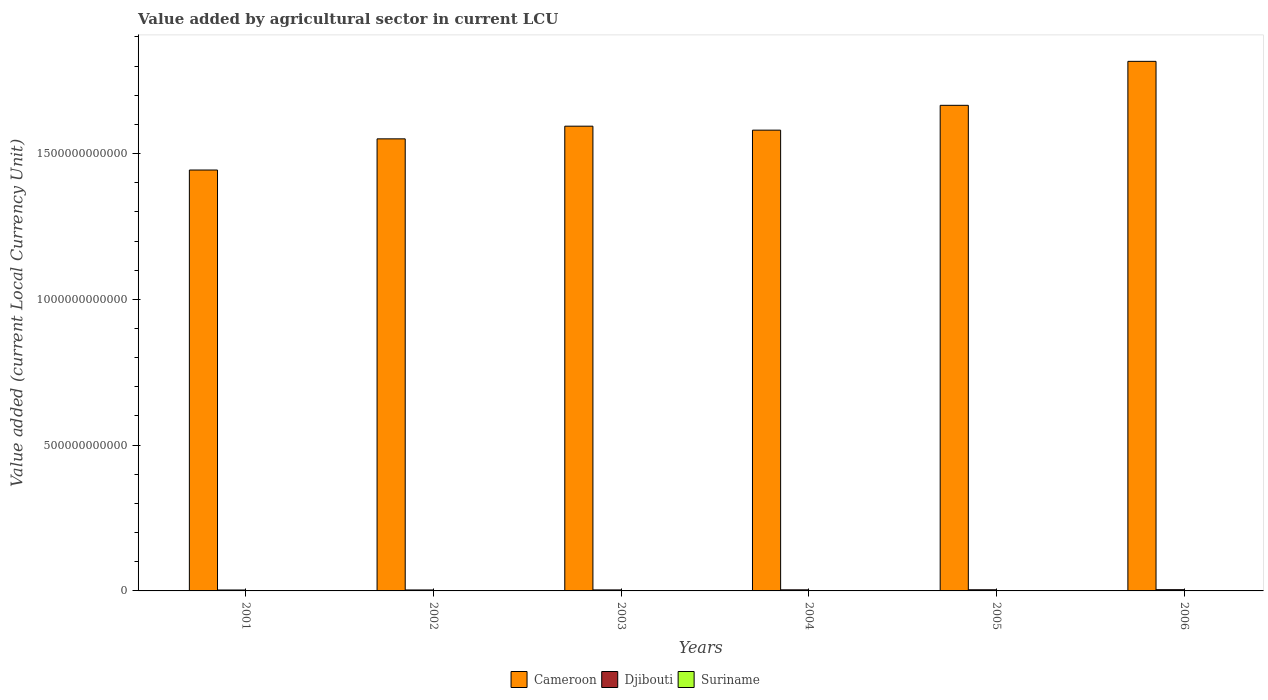Are the number of bars per tick equal to the number of legend labels?
Offer a terse response. Yes. How many bars are there on the 1st tick from the right?
Keep it short and to the point. 3. What is the label of the 4th group of bars from the left?
Your response must be concise. 2004. In how many cases, is the number of bars for a given year not equal to the number of legend labels?
Give a very brief answer. 0. What is the value added by agricultural sector in Djibouti in 2001?
Offer a very short reply. 3.18e+09. Across all years, what is the maximum value added by agricultural sector in Cameroon?
Your answer should be compact. 1.82e+12. Across all years, what is the minimum value added by agricultural sector in Suriname?
Your answer should be compact. 1.65e+08. What is the total value added by agricultural sector in Suriname in the graph?
Keep it short and to the point. 1.75e+09. What is the difference between the value added by agricultural sector in Suriname in 2005 and that in 2006?
Offer a very short reply. -4.93e+08. What is the difference between the value added by agricultural sector in Suriname in 2003 and the value added by agricultural sector in Djibouti in 2004?
Make the answer very short. -3.51e+09. What is the average value added by agricultural sector in Cameroon per year?
Offer a terse response. 1.61e+12. In the year 2006, what is the difference between the value added by agricultural sector in Cameroon and value added by agricultural sector in Suriname?
Provide a succinct answer. 1.82e+12. What is the ratio of the value added by agricultural sector in Djibouti in 2002 to that in 2004?
Provide a short and direct response. 0.88. Is the value added by agricultural sector in Suriname in 2002 less than that in 2003?
Offer a very short reply. Yes. What is the difference between the highest and the second highest value added by agricultural sector in Suriname?
Your answer should be very brief. 4.93e+08. What is the difference between the highest and the lowest value added by agricultural sector in Suriname?
Ensure brevity in your answer.  5.69e+08. Is the sum of the value added by agricultural sector in Djibouti in 2001 and 2004 greater than the maximum value added by agricultural sector in Suriname across all years?
Ensure brevity in your answer.  Yes. What does the 3rd bar from the left in 2003 represents?
Keep it short and to the point. Suriname. What does the 3rd bar from the right in 2002 represents?
Make the answer very short. Cameroon. Is it the case that in every year, the sum of the value added by agricultural sector in Cameroon and value added by agricultural sector in Suriname is greater than the value added by agricultural sector in Djibouti?
Provide a succinct answer. Yes. How many years are there in the graph?
Ensure brevity in your answer.  6. What is the difference between two consecutive major ticks on the Y-axis?
Give a very brief answer. 5.00e+11. Does the graph contain any zero values?
Make the answer very short. No. Does the graph contain grids?
Provide a succinct answer. No. What is the title of the graph?
Your response must be concise. Value added by agricultural sector in current LCU. What is the label or title of the X-axis?
Keep it short and to the point. Years. What is the label or title of the Y-axis?
Give a very brief answer. Value added (current Local Currency Unit). What is the Value added (current Local Currency Unit) in Cameroon in 2001?
Your answer should be very brief. 1.44e+12. What is the Value added (current Local Currency Unit) in Djibouti in 2001?
Offer a very short reply. 3.18e+09. What is the Value added (current Local Currency Unit) of Suriname in 2001?
Provide a short and direct response. 1.65e+08. What is the Value added (current Local Currency Unit) in Cameroon in 2002?
Give a very brief answer. 1.55e+12. What is the Value added (current Local Currency Unit) in Djibouti in 2002?
Provide a succinct answer. 3.29e+09. What is the Value added (current Local Currency Unit) in Suriname in 2002?
Make the answer very short. 1.74e+08. What is the Value added (current Local Currency Unit) of Cameroon in 2003?
Your response must be concise. 1.59e+12. What is the Value added (current Local Currency Unit) of Djibouti in 2003?
Offer a very short reply. 3.46e+09. What is the Value added (current Local Currency Unit) of Suriname in 2003?
Keep it short and to the point. 2.16e+08. What is the Value added (current Local Currency Unit) of Cameroon in 2004?
Provide a succinct answer. 1.58e+12. What is the Value added (current Local Currency Unit) of Djibouti in 2004?
Give a very brief answer. 3.73e+09. What is the Value added (current Local Currency Unit) of Suriname in 2004?
Keep it short and to the point. 2.16e+08. What is the Value added (current Local Currency Unit) in Cameroon in 2005?
Give a very brief answer. 1.67e+12. What is the Value added (current Local Currency Unit) in Djibouti in 2005?
Your answer should be compact. 3.96e+09. What is the Value added (current Local Currency Unit) in Suriname in 2005?
Keep it short and to the point. 2.41e+08. What is the Value added (current Local Currency Unit) of Cameroon in 2006?
Your answer should be compact. 1.82e+12. What is the Value added (current Local Currency Unit) in Djibouti in 2006?
Your answer should be very brief. 4.27e+09. What is the Value added (current Local Currency Unit) of Suriname in 2006?
Keep it short and to the point. 7.34e+08. Across all years, what is the maximum Value added (current Local Currency Unit) in Cameroon?
Your answer should be very brief. 1.82e+12. Across all years, what is the maximum Value added (current Local Currency Unit) of Djibouti?
Provide a succinct answer. 4.27e+09. Across all years, what is the maximum Value added (current Local Currency Unit) in Suriname?
Provide a succinct answer. 7.34e+08. Across all years, what is the minimum Value added (current Local Currency Unit) of Cameroon?
Give a very brief answer. 1.44e+12. Across all years, what is the minimum Value added (current Local Currency Unit) in Djibouti?
Offer a very short reply. 3.18e+09. Across all years, what is the minimum Value added (current Local Currency Unit) of Suriname?
Your answer should be very brief. 1.65e+08. What is the total Value added (current Local Currency Unit) in Cameroon in the graph?
Your answer should be very brief. 9.65e+12. What is the total Value added (current Local Currency Unit) of Djibouti in the graph?
Give a very brief answer. 2.19e+1. What is the total Value added (current Local Currency Unit) of Suriname in the graph?
Your response must be concise. 1.75e+09. What is the difference between the Value added (current Local Currency Unit) in Cameroon in 2001 and that in 2002?
Keep it short and to the point. -1.07e+11. What is the difference between the Value added (current Local Currency Unit) of Djibouti in 2001 and that in 2002?
Provide a short and direct response. -1.16e+08. What is the difference between the Value added (current Local Currency Unit) in Suriname in 2001 and that in 2002?
Provide a succinct answer. -8.16e+06. What is the difference between the Value added (current Local Currency Unit) of Cameroon in 2001 and that in 2003?
Keep it short and to the point. -1.50e+11. What is the difference between the Value added (current Local Currency Unit) in Djibouti in 2001 and that in 2003?
Give a very brief answer. -2.82e+08. What is the difference between the Value added (current Local Currency Unit) of Suriname in 2001 and that in 2003?
Your answer should be very brief. -5.09e+07. What is the difference between the Value added (current Local Currency Unit) of Cameroon in 2001 and that in 2004?
Make the answer very short. -1.37e+11. What is the difference between the Value added (current Local Currency Unit) in Djibouti in 2001 and that in 2004?
Provide a short and direct response. -5.50e+08. What is the difference between the Value added (current Local Currency Unit) in Suriname in 2001 and that in 2004?
Offer a very short reply. -5.09e+07. What is the difference between the Value added (current Local Currency Unit) of Cameroon in 2001 and that in 2005?
Ensure brevity in your answer.  -2.22e+11. What is the difference between the Value added (current Local Currency Unit) in Djibouti in 2001 and that in 2005?
Give a very brief answer. -7.82e+08. What is the difference between the Value added (current Local Currency Unit) of Suriname in 2001 and that in 2005?
Provide a succinct answer. -7.56e+07. What is the difference between the Value added (current Local Currency Unit) in Cameroon in 2001 and that in 2006?
Make the answer very short. -3.73e+11. What is the difference between the Value added (current Local Currency Unit) of Djibouti in 2001 and that in 2006?
Provide a succinct answer. -1.10e+09. What is the difference between the Value added (current Local Currency Unit) of Suriname in 2001 and that in 2006?
Make the answer very short. -5.69e+08. What is the difference between the Value added (current Local Currency Unit) in Cameroon in 2002 and that in 2003?
Provide a short and direct response. -4.34e+1. What is the difference between the Value added (current Local Currency Unit) in Djibouti in 2002 and that in 2003?
Provide a short and direct response. -1.66e+08. What is the difference between the Value added (current Local Currency Unit) of Suriname in 2002 and that in 2003?
Your answer should be very brief. -4.27e+07. What is the difference between the Value added (current Local Currency Unit) of Cameroon in 2002 and that in 2004?
Keep it short and to the point. -2.98e+1. What is the difference between the Value added (current Local Currency Unit) of Djibouti in 2002 and that in 2004?
Keep it short and to the point. -4.34e+08. What is the difference between the Value added (current Local Currency Unit) of Suriname in 2002 and that in 2004?
Your response must be concise. -4.27e+07. What is the difference between the Value added (current Local Currency Unit) in Cameroon in 2002 and that in 2005?
Your answer should be very brief. -1.15e+11. What is the difference between the Value added (current Local Currency Unit) in Djibouti in 2002 and that in 2005?
Provide a succinct answer. -6.66e+08. What is the difference between the Value added (current Local Currency Unit) in Suriname in 2002 and that in 2005?
Offer a terse response. -6.75e+07. What is the difference between the Value added (current Local Currency Unit) of Cameroon in 2002 and that in 2006?
Offer a very short reply. -2.66e+11. What is the difference between the Value added (current Local Currency Unit) in Djibouti in 2002 and that in 2006?
Your answer should be very brief. -9.79e+08. What is the difference between the Value added (current Local Currency Unit) of Suriname in 2002 and that in 2006?
Ensure brevity in your answer.  -5.60e+08. What is the difference between the Value added (current Local Currency Unit) in Cameroon in 2003 and that in 2004?
Provide a succinct answer. 1.36e+1. What is the difference between the Value added (current Local Currency Unit) in Djibouti in 2003 and that in 2004?
Your answer should be very brief. -2.68e+08. What is the difference between the Value added (current Local Currency Unit) in Suriname in 2003 and that in 2004?
Provide a short and direct response. -2000. What is the difference between the Value added (current Local Currency Unit) of Cameroon in 2003 and that in 2005?
Provide a short and direct response. -7.15e+1. What is the difference between the Value added (current Local Currency Unit) of Djibouti in 2003 and that in 2005?
Give a very brief answer. -5.00e+08. What is the difference between the Value added (current Local Currency Unit) of Suriname in 2003 and that in 2005?
Ensure brevity in your answer.  -2.47e+07. What is the difference between the Value added (current Local Currency Unit) of Cameroon in 2003 and that in 2006?
Provide a short and direct response. -2.22e+11. What is the difference between the Value added (current Local Currency Unit) of Djibouti in 2003 and that in 2006?
Your answer should be very brief. -8.14e+08. What is the difference between the Value added (current Local Currency Unit) in Suriname in 2003 and that in 2006?
Offer a terse response. -5.18e+08. What is the difference between the Value added (current Local Currency Unit) of Cameroon in 2004 and that in 2005?
Keep it short and to the point. -8.52e+1. What is the difference between the Value added (current Local Currency Unit) of Djibouti in 2004 and that in 2005?
Offer a terse response. -2.32e+08. What is the difference between the Value added (current Local Currency Unit) in Suriname in 2004 and that in 2005?
Provide a short and direct response. -2.47e+07. What is the difference between the Value added (current Local Currency Unit) in Cameroon in 2004 and that in 2006?
Keep it short and to the point. -2.36e+11. What is the difference between the Value added (current Local Currency Unit) of Djibouti in 2004 and that in 2006?
Provide a short and direct response. -5.45e+08. What is the difference between the Value added (current Local Currency Unit) of Suriname in 2004 and that in 2006?
Your answer should be compact. -5.18e+08. What is the difference between the Value added (current Local Currency Unit) of Cameroon in 2005 and that in 2006?
Offer a terse response. -1.51e+11. What is the difference between the Value added (current Local Currency Unit) of Djibouti in 2005 and that in 2006?
Your answer should be compact. -3.14e+08. What is the difference between the Value added (current Local Currency Unit) in Suriname in 2005 and that in 2006?
Keep it short and to the point. -4.93e+08. What is the difference between the Value added (current Local Currency Unit) in Cameroon in 2001 and the Value added (current Local Currency Unit) in Djibouti in 2002?
Provide a succinct answer. 1.44e+12. What is the difference between the Value added (current Local Currency Unit) in Cameroon in 2001 and the Value added (current Local Currency Unit) in Suriname in 2002?
Keep it short and to the point. 1.44e+12. What is the difference between the Value added (current Local Currency Unit) in Djibouti in 2001 and the Value added (current Local Currency Unit) in Suriname in 2002?
Offer a terse response. 3.00e+09. What is the difference between the Value added (current Local Currency Unit) of Cameroon in 2001 and the Value added (current Local Currency Unit) of Djibouti in 2003?
Your response must be concise. 1.44e+12. What is the difference between the Value added (current Local Currency Unit) of Cameroon in 2001 and the Value added (current Local Currency Unit) of Suriname in 2003?
Offer a very short reply. 1.44e+12. What is the difference between the Value added (current Local Currency Unit) in Djibouti in 2001 and the Value added (current Local Currency Unit) in Suriname in 2003?
Give a very brief answer. 2.96e+09. What is the difference between the Value added (current Local Currency Unit) in Cameroon in 2001 and the Value added (current Local Currency Unit) in Djibouti in 2004?
Ensure brevity in your answer.  1.44e+12. What is the difference between the Value added (current Local Currency Unit) in Cameroon in 2001 and the Value added (current Local Currency Unit) in Suriname in 2004?
Provide a short and direct response. 1.44e+12. What is the difference between the Value added (current Local Currency Unit) in Djibouti in 2001 and the Value added (current Local Currency Unit) in Suriname in 2004?
Provide a short and direct response. 2.96e+09. What is the difference between the Value added (current Local Currency Unit) of Cameroon in 2001 and the Value added (current Local Currency Unit) of Djibouti in 2005?
Your answer should be very brief. 1.44e+12. What is the difference between the Value added (current Local Currency Unit) in Cameroon in 2001 and the Value added (current Local Currency Unit) in Suriname in 2005?
Make the answer very short. 1.44e+12. What is the difference between the Value added (current Local Currency Unit) of Djibouti in 2001 and the Value added (current Local Currency Unit) of Suriname in 2005?
Your answer should be very brief. 2.94e+09. What is the difference between the Value added (current Local Currency Unit) of Cameroon in 2001 and the Value added (current Local Currency Unit) of Djibouti in 2006?
Offer a terse response. 1.44e+12. What is the difference between the Value added (current Local Currency Unit) of Cameroon in 2001 and the Value added (current Local Currency Unit) of Suriname in 2006?
Ensure brevity in your answer.  1.44e+12. What is the difference between the Value added (current Local Currency Unit) of Djibouti in 2001 and the Value added (current Local Currency Unit) of Suriname in 2006?
Offer a terse response. 2.44e+09. What is the difference between the Value added (current Local Currency Unit) in Cameroon in 2002 and the Value added (current Local Currency Unit) in Djibouti in 2003?
Offer a terse response. 1.55e+12. What is the difference between the Value added (current Local Currency Unit) in Cameroon in 2002 and the Value added (current Local Currency Unit) in Suriname in 2003?
Provide a succinct answer. 1.55e+12. What is the difference between the Value added (current Local Currency Unit) of Djibouti in 2002 and the Value added (current Local Currency Unit) of Suriname in 2003?
Your answer should be very brief. 3.08e+09. What is the difference between the Value added (current Local Currency Unit) in Cameroon in 2002 and the Value added (current Local Currency Unit) in Djibouti in 2004?
Offer a very short reply. 1.55e+12. What is the difference between the Value added (current Local Currency Unit) of Cameroon in 2002 and the Value added (current Local Currency Unit) of Suriname in 2004?
Ensure brevity in your answer.  1.55e+12. What is the difference between the Value added (current Local Currency Unit) of Djibouti in 2002 and the Value added (current Local Currency Unit) of Suriname in 2004?
Your answer should be very brief. 3.08e+09. What is the difference between the Value added (current Local Currency Unit) of Cameroon in 2002 and the Value added (current Local Currency Unit) of Djibouti in 2005?
Give a very brief answer. 1.55e+12. What is the difference between the Value added (current Local Currency Unit) in Cameroon in 2002 and the Value added (current Local Currency Unit) in Suriname in 2005?
Your answer should be compact. 1.55e+12. What is the difference between the Value added (current Local Currency Unit) in Djibouti in 2002 and the Value added (current Local Currency Unit) in Suriname in 2005?
Your response must be concise. 3.05e+09. What is the difference between the Value added (current Local Currency Unit) of Cameroon in 2002 and the Value added (current Local Currency Unit) of Djibouti in 2006?
Your answer should be compact. 1.55e+12. What is the difference between the Value added (current Local Currency Unit) in Cameroon in 2002 and the Value added (current Local Currency Unit) in Suriname in 2006?
Give a very brief answer. 1.55e+12. What is the difference between the Value added (current Local Currency Unit) of Djibouti in 2002 and the Value added (current Local Currency Unit) of Suriname in 2006?
Provide a succinct answer. 2.56e+09. What is the difference between the Value added (current Local Currency Unit) of Cameroon in 2003 and the Value added (current Local Currency Unit) of Djibouti in 2004?
Your response must be concise. 1.59e+12. What is the difference between the Value added (current Local Currency Unit) in Cameroon in 2003 and the Value added (current Local Currency Unit) in Suriname in 2004?
Keep it short and to the point. 1.59e+12. What is the difference between the Value added (current Local Currency Unit) of Djibouti in 2003 and the Value added (current Local Currency Unit) of Suriname in 2004?
Your answer should be very brief. 3.24e+09. What is the difference between the Value added (current Local Currency Unit) of Cameroon in 2003 and the Value added (current Local Currency Unit) of Djibouti in 2005?
Give a very brief answer. 1.59e+12. What is the difference between the Value added (current Local Currency Unit) of Cameroon in 2003 and the Value added (current Local Currency Unit) of Suriname in 2005?
Make the answer very short. 1.59e+12. What is the difference between the Value added (current Local Currency Unit) of Djibouti in 2003 and the Value added (current Local Currency Unit) of Suriname in 2005?
Make the answer very short. 3.22e+09. What is the difference between the Value added (current Local Currency Unit) of Cameroon in 2003 and the Value added (current Local Currency Unit) of Djibouti in 2006?
Provide a succinct answer. 1.59e+12. What is the difference between the Value added (current Local Currency Unit) of Cameroon in 2003 and the Value added (current Local Currency Unit) of Suriname in 2006?
Your answer should be very brief. 1.59e+12. What is the difference between the Value added (current Local Currency Unit) of Djibouti in 2003 and the Value added (current Local Currency Unit) of Suriname in 2006?
Provide a succinct answer. 2.73e+09. What is the difference between the Value added (current Local Currency Unit) in Cameroon in 2004 and the Value added (current Local Currency Unit) in Djibouti in 2005?
Your answer should be very brief. 1.58e+12. What is the difference between the Value added (current Local Currency Unit) in Cameroon in 2004 and the Value added (current Local Currency Unit) in Suriname in 2005?
Give a very brief answer. 1.58e+12. What is the difference between the Value added (current Local Currency Unit) in Djibouti in 2004 and the Value added (current Local Currency Unit) in Suriname in 2005?
Your response must be concise. 3.49e+09. What is the difference between the Value added (current Local Currency Unit) in Cameroon in 2004 and the Value added (current Local Currency Unit) in Djibouti in 2006?
Your response must be concise. 1.58e+12. What is the difference between the Value added (current Local Currency Unit) in Cameroon in 2004 and the Value added (current Local Currency Unit) in Suriname in 2006?
Provide a succinct answer. 1.58e+12. What is the difference between the Value added (current Local Currency Unit) in Djibouti in 2004 and the Value added (current Local Currency Unit) in Suriname in 2006?
Make the answer very short. 2.99e+09. What is the difference between the Value added (current Local Currency Unit) of Cameroon in 2005 and the Value added (current Local Currency Unit) of Djibouti in 2006?
Offer a very short reply. 1.66e+12. What is the difference between the Value added (current Local Currency Unit) of Cameroon in 2005 and the Value added (current Local Currency Unit) of Suriname in 2006?
Give a very brief answer. 1.66e+12. What is the difference between the Value added (current Local Currency Unit) of Djibouti in 2005 and the Value added (current Local Currency Unit) of Suriname in 2006?
Your answer should be compact. 3.23e+09. What is the average Value added (current Local Currency Unit) in Cameroon per year?
Your answer should be compact. 1.61e+12. What is the average Value added (current Local Currency Unit) in Djibouti per year?
Ensure brevity in your answer.  3.65e+09. What is the average Value added (current Local Currency Unit) in Suriname per year?
Offer a very short reply. 2.91e+08. In the year 2001, what is the difference between the Value added (current Local Currency Unit) of Cameroon and Value added (current Local Currency Unit) of Djibouti?
Offer a very short reply. 1.44e+12. In the year 2001, what is the difference between the Value added (current Local Currency Unit) in Cameroon and Value added (current Local Currency Unit) in Suriname?
Offer a terse response. 1.44e+12. In the year 2001, what is the difference between the Value added (current Local Currency Unit) of Djibouti and Value added (current Local Currency Unit) of Suriname?
Offer a terse response. 3.01e+09. In the year 2002, what is the difference between the Value added (current Local Currency Unit) in Cameroon and Value added (current Local Currency Unit) in Djibouti?
Offer a very short reply. 1.55e+12. In the year 2002, what is the difference between the Value added (current Local Currency Unit) of Cameroon and Value added (current Local Currency Unit) of Suriname?
Offer a terse response. 1.55e+12. In the year 2002, what is the difference between the Value added (current Local Currency Unit) of Djibouti and Value added (current Local Currency Unit) of Suriname?
Offer a very short reply. 3.12e+09. In the year 2003, what is the difference between the Value added (current Local Currency Unit) in Cameroon and Value added (current Local Currency Unit) in Djibouti?
Make the answer very short. 1.59e+12. In the year 2003, what is the difference between the Value added (current Local Currency Unit) of Cameroon and Value added (current Local Currency Unit) of Suriname?
Provide a short and direct response. 1.59e+12. In the year 2003, what is the difference between the Value added (current Local Currency Unit) of Djibouti and Value added (current Local Currency Unit) of Suriname?
Give a very brief answer. 3.24e+09. In the year 2004, what is the difference between the Value added (current Local Currency Unit) in Cameroon and Value added (current Local Currency Unit) in Djibouti?
Keep it short and to the point. 1.58e+12. In the year 2004, what is the difference between the Value added (current Local Currency Unit) in Cameroon and Value added (current Local Currency Unit) in Suriname?
Give a very brief answer. 1.58e+12. In the year 2004, what is the difference between the Value added (current Local Currency Unit) in Djibouti and Value added (current Local Currency Unit) in Suriname?
Provide a short and direct response. 3.51e+09. In the year 2005, what is the difference between the Value added (current Local Currency Unit) of Cameroon and Value added (current Local Currency Unit) of Djibouti?
Offer a very short reply. 1.66e+12. In the year 2005, what is the difference between the Value added (current Local Currency Unit) of Cameroon and Value added (current Local Currency Unit) of Suriname?
Provide a succinct answer. 1.67e+12. In the year 2005, what is the difference between the Value added (current Local Currency Unit) in Djibouti and Value added (current Local Currency Unit) in Suriname?
Offer a very short reply. 3.72e+09. In the year 2006, what is the difference between the Value added (current Local Currency Unit) in Cameroon and Value added (current Local Currency Unit) in Djibouti?
Provide a short and direct response. 1.81e+12. In the year 2006, what is the difference between the Value added (current Local Currency Unit) in Cameroon and Value added (current Local Currency Unit) in Suriname?
Offer a terse response. 1.82e+12. In the year 2006, what is the difference between the Value added (current Local Currency Unit) in Djibouti and Value added (current Local Currency Unit) in Suriname?
Your answer should be very brief. 3.54e+09. What is the ratio of the Value added (current Local Currency Unit) of Cameroon in 2001 to that in 2002?
Your response must be concise. 0.93. What is the ratio of the Value added (current Local Currency Unit) of Djibouti in 2001 to that in 2002?
Ensure brevity in your answer.  0.96. What is the ratio of the Value added (current Local Currency Unit) in Suriname in 2001 to that in 2002?
Provide a succinct answer. 0.95. What is the ratio of the Value added (current Local Currency Unit) in Cameroon in 2001 to that in 2003?
Make the answer very short. 0.91. What is the ratio of the Value added (current Local Currency Unit) in Djibouti in 2001 to that in 2003?
Your answer should be very brief. 0.92. What is the ratio of the Value added (current Local Currency Unit) in Suriname in 2001 to that in 2003?
Offer a terse response. 0.76. What is the ratio of the Value added (current Local Currency Unit) in Cameroon in 2001 to that in 2004?
Ensure brevity in your answer.  0.91. What is the ratio of the Value added (current Local Currency Unit) of Djibouti in 2001 to that in 2004?
Your response must be concise. 0.85. What is the ratio of the Value added (current Local Currency Unit) in Suriname in 2001 to that in 2004?
Your answer should be very brief. 0.76. What is the ratio of the Value added (current Local Currency Unit) in Cameroon in 2001 to that in 2005?
Your answer should be compact. 0.87. What is the ratio of the Value added (current Local Currency Unit) in Djibouti in 2001 to that in 2005?
Give a very brief answer. 0.8. What is the ratio of the Value added (current Local Currency Unit) of Suriname in 2001 to that in 2005?
Offer a terse response. 0.69. What is the ratio of the Value added (current Local Currency Unit) of Cameroon in 2001 to that in 2006?
Give a very brief answer. 0.79. What is the ratio of the Value added (current Local Currency Unit) of Djibouti in 2001 to that in 2006?
Offer a terse response. 0.74. What is the ratio of the Value added (current Local Currency Unit) in Suriname in 2001 to that in 2006?
Provide a succinct answer. 0.23. What is the ratio of the Value added (current Local Currency Unit) of Cameroon in 2002 to that in 2003?
Your answer should be compact. 0.97. What is the ratio of the Value added (current Local Currency Unit) in Djibouti in 2002 to that in 2003?
Give a very brief answer. 0.95. What is the ratio of the Value added (current Local Currency Unit) in Suriname in 2002 to that in 2003?
Offer a very short reply. 0.8. What is the ratio of the Value added (current Local Currency Unit) in Cameroon in 2002 to that in 2004?
Keep it short and to the point. 0.98. What is the ratio of the Value added (current Local Currency Unit) in Djibouti in 2002 to that in 2004?
Give a very brief answer. 0.88. What is the ratio of the Value added (current Local Currency Unit) of Suriname in 2002 to that in 2004?
Make the answer very short. 0.8. What is the ratio of the Value added (current Local Currency Unit) of Cameroon in 2002 to that in 2005?
Give a very brief answer. 0.93. What is the ratio of the Value added (current Local Currency Unit) of Djibouti in 2002 to that in 2005?
Offer a very short reply. 0.83. What is the ratio of the Value added (current Local Currency Unit) in Suriname in 2002 to that in 2005?
Provide a succinct answer. 0.72. What is the ratio of the Value added (current Local Currency Unit) in Cameroon in 2002 to that in 2006?
Your answer should be very brief. 0.85. What is the ratio of the Value added (current Local Currency Unit) in Djibouti in 2002 to that in 2006?
Your response must be concise. 0.77. What is the ratio of the Value added (current Local Currency Unit) of Suriname in 2002 to that in 2006?
Provide a succinct answer. 0.24. What is the ratio of the Value added (current Local Currency Unit) of Cameroon in 2003 to that in 2004?
Provide a succinct answer. 1.01. What is the ratio of the Value added (current Local Currency Unit) of Djibouti in 2003 to that in 2004?
Provide a succinct answer. 0.93. What is the ratio of the Value added (current Local Currency Unit) in Cameroon in 2003 to that in 2005?
Ensure brevity in your answer.  0.96. What is the ratio of the Value added (current Local Currency Unit) in Djibouti in 2003 to that in 2005?
Offer a terse response. 0.87. What is the ratio of the Value added (current Local Currency Unit) of Suriname in 2003 to that in 2005?
Give a very brief answer. 0.9. What is the ratio of the Value added (current Local Currency Unit) in Cameroon in 2003 to that in 2006?
Ensure brevity in your answer.  0.88. What is the ratio of the Value added (current Local Currency Unit) of Djibouti in 2003 to that in 2006?
Your answer should be very brief. 0.81. What is the ratio of the Value added (current Local Currency Unit) in Suriname in 2003 to that in 2006?
Give a very brief answer. 0.29. What is the ratio of the Value added (current Local Currency Unit) in Cameroon in 2004 to that in 2005?
Your answer should be compact. 0.95. What is the ratio of the Value added (current Local Currency Unit) of Djibouti in 2004 to that in 2005?
Your response must be concise. 0.94. What is the ratio of the Value added (current Local Currency Unit) of Suriname in 2004 to that in 2005?
Offer a terse response. 0.9. What is the ratio of the Value added (current Local Currency Unit) in Cameroon in 2004 to that in 2006?
Your answer should be compact. 0.87. What is the ratio of the Value added (current Local Currency Unit) in Djibouti in 2004 to that in 2006?
Your response must be concise. 0.87. What is the ratio of the Value added (current Local Currency Unit) of Suriname in 2004 to that in 2006?
Make the answer very short. 0.29. What is the ratio of the Value added (current Local Currency Unit) in Cameroon in 2005 to that in 2006?
Offer a very short reply. 0.92. What is the ratio of the Value added (current Local Currency Unit) of Djibouti in 2005 to that in 2006?
Your answer should be compact. 0.93. What is the ratio of the Value added (current Local Currency Unit) in Suriname in 2005 to that in 2006?
Make the answer very short. 0.33. What is the difference between the highest and the second highest Value added (current Local Currency Unit) of Cameroon?
Give a very brief answer. 1.51e+11. What is the difference between the highest and the second highest Value added (current Local Currency Unit) in Djibouti?
Give a very brief answer. 3.14e+08. What is the difference between the highest and the second highest Value added (current Local Currency Unit) of Suriname?
Give a very brief answer. 4.93e+08. What is the difference between the highest and the lowest Value added (current Local Currency Unit) of Cameroon?
Your answer should be compact. 3.73e+11. What is the difference between the highest and the lowest Value added (current Local Currency Unit) in Djibouti?
Your answer should be compact. 1.10e+09. What is the difference between the highest and the lowest Value added (current Local Currency Unit) of Suriname?
Provide a short and direct response. 5.69e+08. 